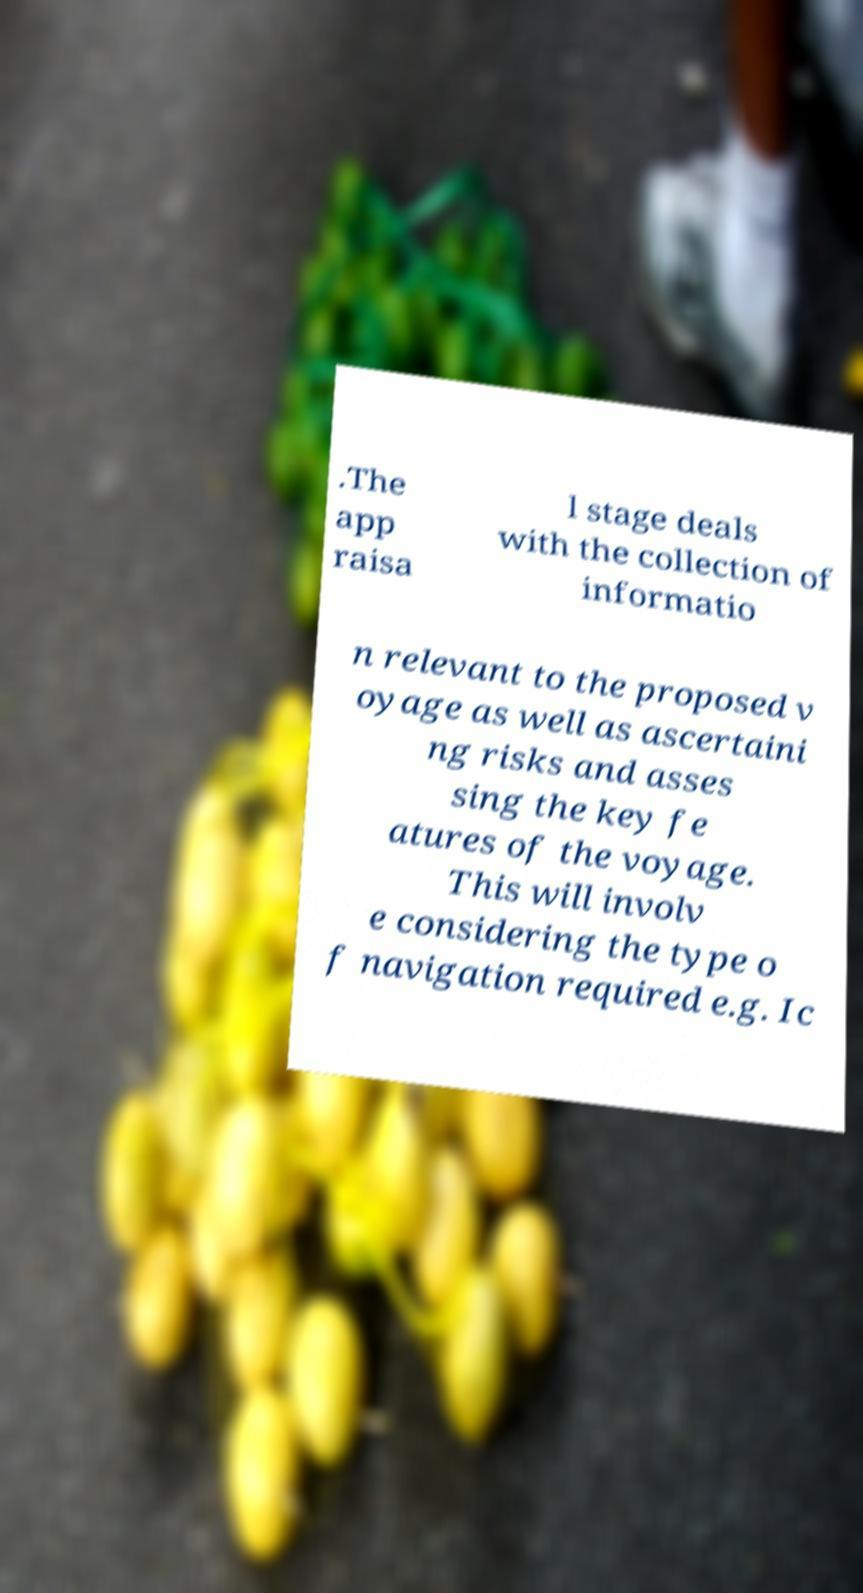There's text embedded in this image that I need extracted. Can you transcribe it verbatim? .The app raisa l stage deals with the collection of informatio n relevant to the proposed v oyage as well as ascertaini ng risks and asses sing the key fe atures of the voyage. This will involv e considering the type o f navigation required e.g. Ic 